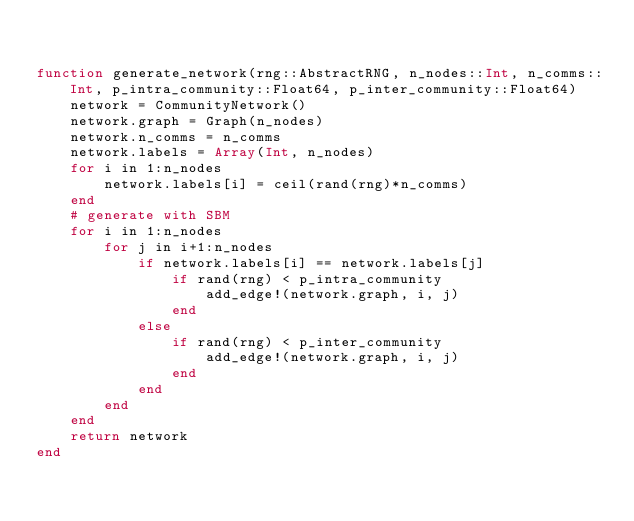<code> <loc_0><loc_0><loc_500><loc_500><_Julia_>

function generate_network(rng::AbstractRNG, n_nodes::Int, n_comms::Int, p_intra_community::Float64, p_inter_community::Float64)
    network = CommunityNetwork()
    network.graph = Graph(n_nodes)
    network.n_comms = n_comms
    network.labels = Array(Int, n_nodes)
    for i in 1:n_nodes
        network.labels[i] = ceil(rand(rng)*n_comms)
    end
    # generate with SBM
    for i in 1:n_nodes
        for j in i+1:n_nodes
            if network.labels[i] == network.labels[j]
                if rand(rng) < p_intra_community
                    add_edge!(network.graph, i, j)
                end
            else
                if rand(rng) < p_inter_community
                    add_edge!(network.graph, i, j)
                end
            end
        end
    end
    return network
end
</code> 